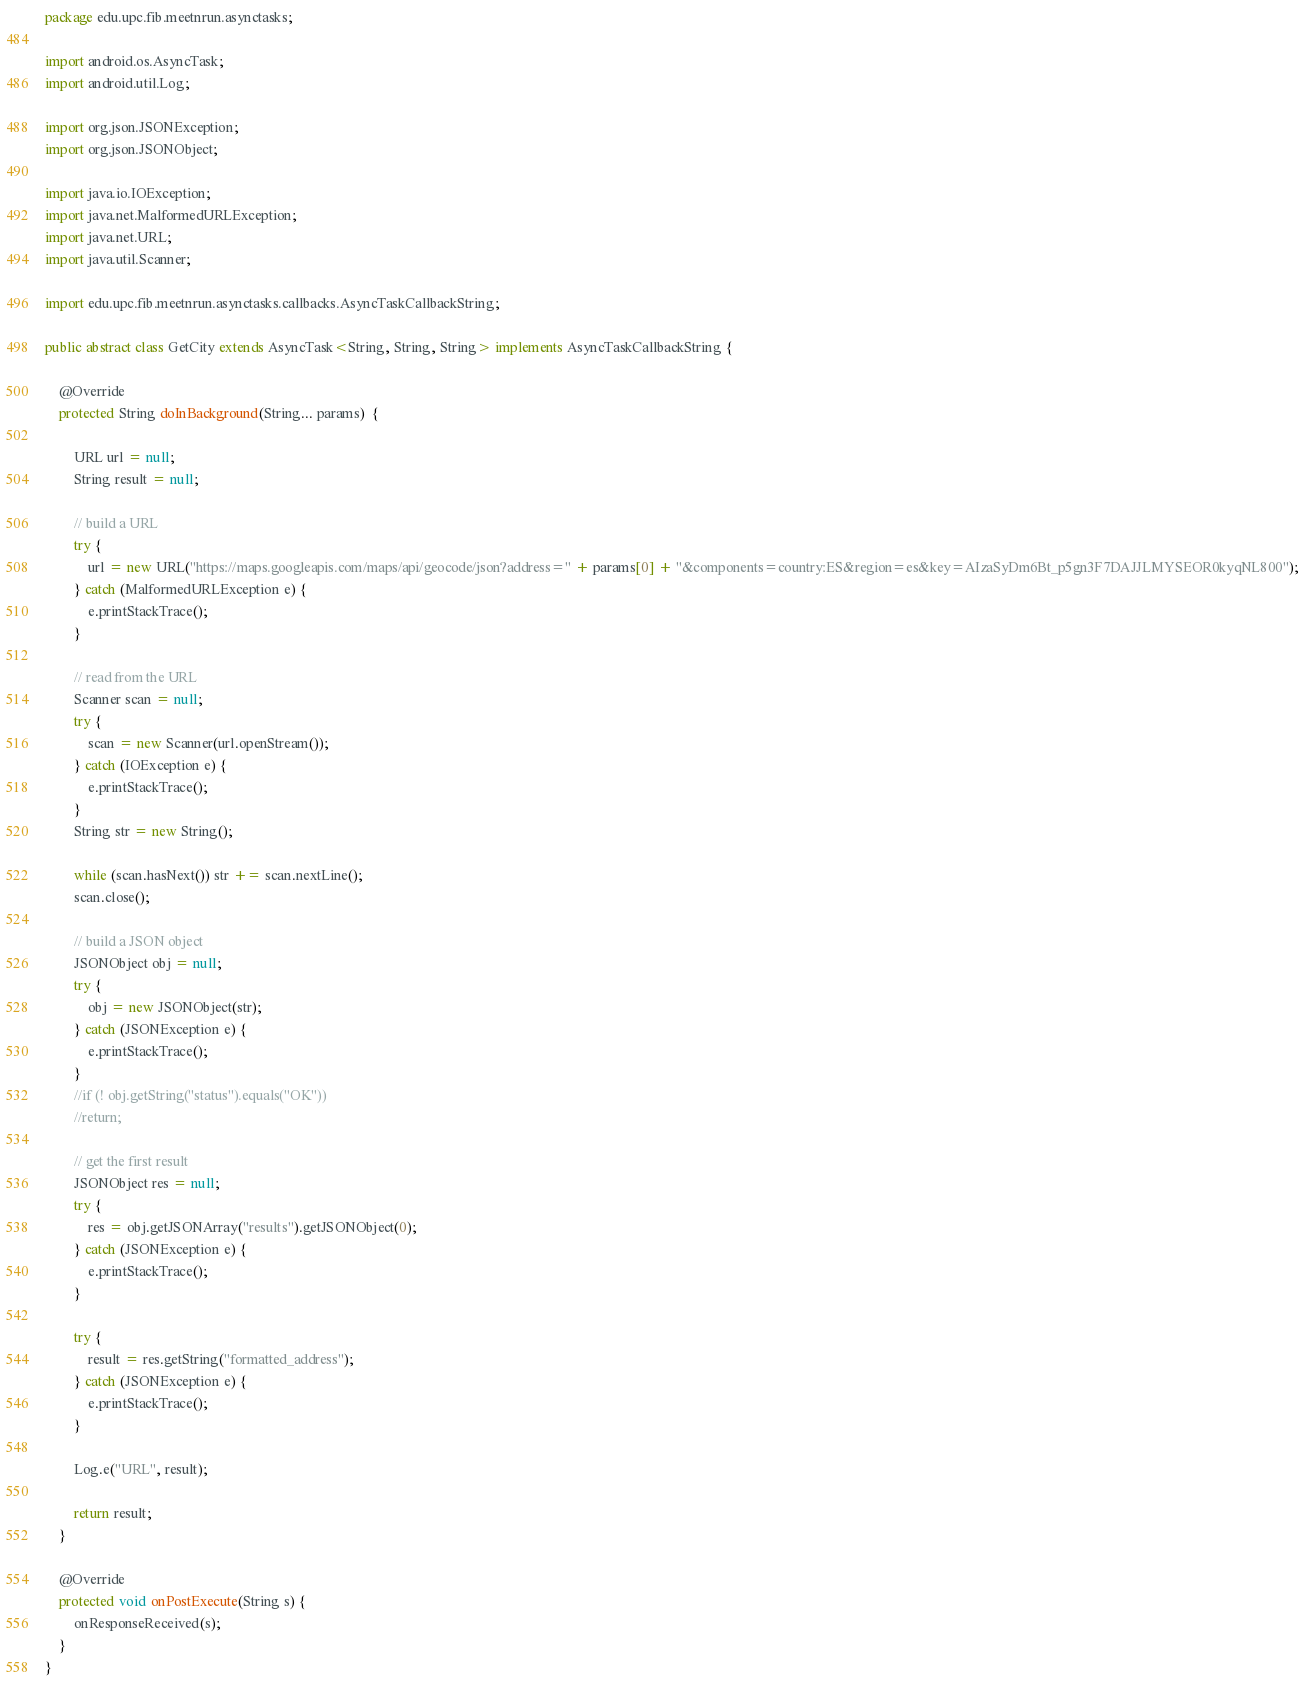<code> <loc_0><loc_0><loc_500><loc_500><_Java_>package edu.upc.fib.meetnrun.asynctasks;

import android.os.AsyncTask;
import android.util.Log;

import org.json.JSONException;
import org.json.JSONObject;

import java.io.IOException;
import java.net.MalformedURLException;
import java.net.URL;
import java.util.Scanner;

import edu.upc.fib.meetnrun.asynctasks.callbacks.AsyncTaskCallbackString;

public abstract class GetCity extends AsyncTask<String, String, String> implements AsyncTaskCallbackString {

    @Override
    protected String doInBackground(String... params)  {

        URL url = null;
        String result = null;

        // build a URL
        try {
            url = new URL("https://maps.googleapis.com/maps/api/geocode/json?address=" + params[0] + "&components=country:ES&region=es&key=AIzaSyDm6Bt_p5gn3F7DAJJLMYSEOR0kyqNL800");
        } catch (MalformedURLException e) {
            e.printStackTrace();
        }

        // read from the URL
        Scanner scan = null;
        try {
            scan = new Scanner(url.openStream());
        } catch (IOException e) {
            e.printStackTrace();
        }
        String str = new String();

        while (scan.hasNext()) str += scan.nextLine();
        scan.close();

        // build a JSON object
        JSONObject obj = null;
        try {
            obj = new JSONObject(str);
        } catch (JSONException e) {
            e.printStackTrace();
        }
        //if (! obj.getString("status").equals("OK"))
        //return;

        // get the first result
        JSONObject res = null;
        try {
            res = obj.getJSONArray("results").getJSONObject(0);
        } catch (JSONException e) {
            e.printStackTrace();
        }

        try {
            result = res.getString("formatted_address");
        } catch (JSONException e) {
            e.printStackTrace();
        }

        Log.e("URL", result);

        return result;
    }

    @Override
    protected void onPostExecute(String s) {
        onResponseReceived(s);
    }
}</code> 